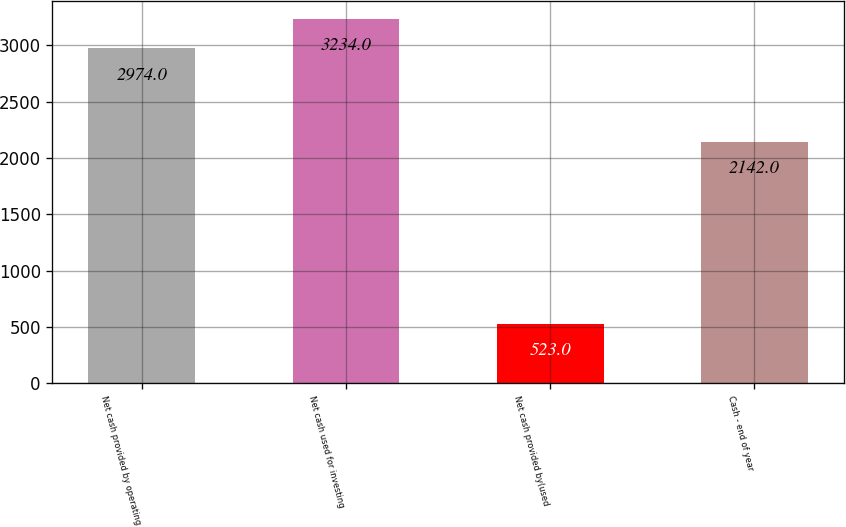<chart> <loc_0><loc_0><loc_500><loc_500><bar_chart><fcel>Net cash provided by operating<fcel>Net cash used for investing<fcel>Net cash provided by(used<fcel>Cash - end of year<nl><fcel>2974<fcel>3234<fcel>523<fcel>2142<nl></chart> 